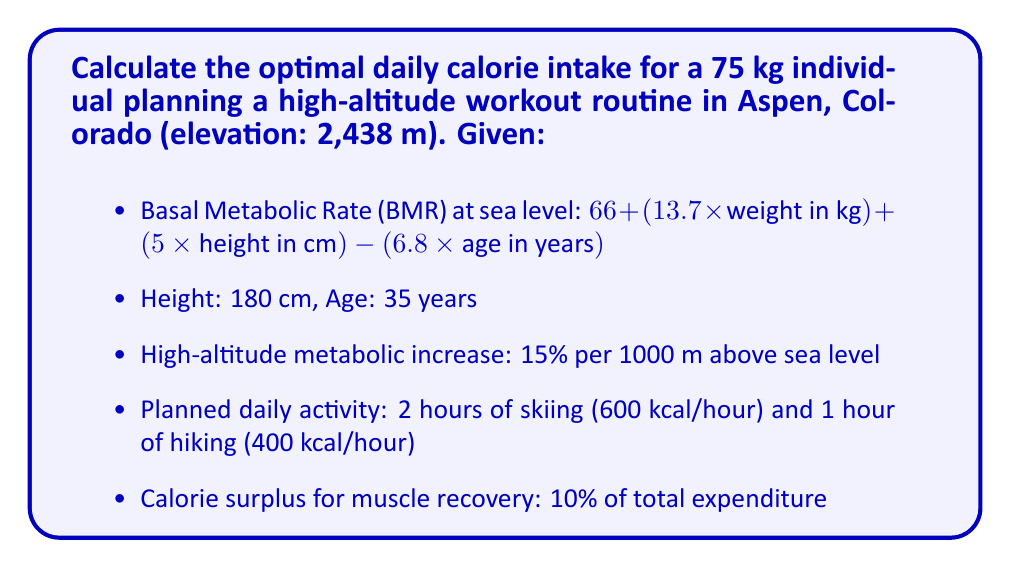Show me your answer to this math problem. 1. Calculate BMR at sea level:
   $$\text{BMR} = 66 + (13.7 \times 75) + (5 \times 180) - (6.8 \times 35)$$
   $$\text{BMR} = 66 + 1027.5 + 900 - 238 = 1755.5 \text{ kcal}$$

2. Calculate the metabolic increase due to altitude:
   Elevation increase: $2438 \text{ m}$
   Metabolic increase: $2.438 \times 15\% = 36.57\%$
   Adjusted BMR: $1755.5 \times 1.3657 = 2397.5 \text{ kcal}$

3. Calculate calories burned during activities:
   Skiing: $600 \text{ kcal/hour} \times 2 \text{ hours} = 1200 \text{ kcal}$
   Hiking: $400 \text{ kcal/hour} \times 1 \text{ hour} = 400 \text{ kcal}$
   Total activity calories: $1200 + 400 = 1600 \text{ kcal}$

4. Calculate total daily energy expenditure:
   $$\text{Total} = \text{Adjusted BMR} + \text{Activity calories}$$
   $$\text{Total} = 2397.5 + 1600 = 3997.5 \text{ kcal}$$

5. Add 10% surplus for muscle recovery:
   $$\text{Optimal intake} = 3997.5 \times 1.10 = 4397.25 \text{ kcal}$$

6. Round to the nearest 10 kcal:
   $$\text{Optimal intake} = 4400 \text{ kcal}$$
Answer: 4400 kcal 